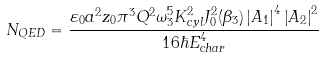Convert formula to latex. <formula><loc_0><loc_0><loc_500><loc_500>N _ { Q E D } = \frac { \varepsilon _ { 0 } a ^ { 2 } z _ { 0 } \pi ^ { 3 } Q ^ { 2 } \omega _ { 3 } ^ { 5 } K _ { c y l } ^ { 2 } J _ { 0 } ^ { 2 } ( \beta _ { 3 } ) \left | A _ { 1 } \right | ^ { 4 } \left | A _ { 2 } \right | ^ { 2 } } { 1 6 \hbar { E } _ { c h a r } ^ { 4 } }</formula> 